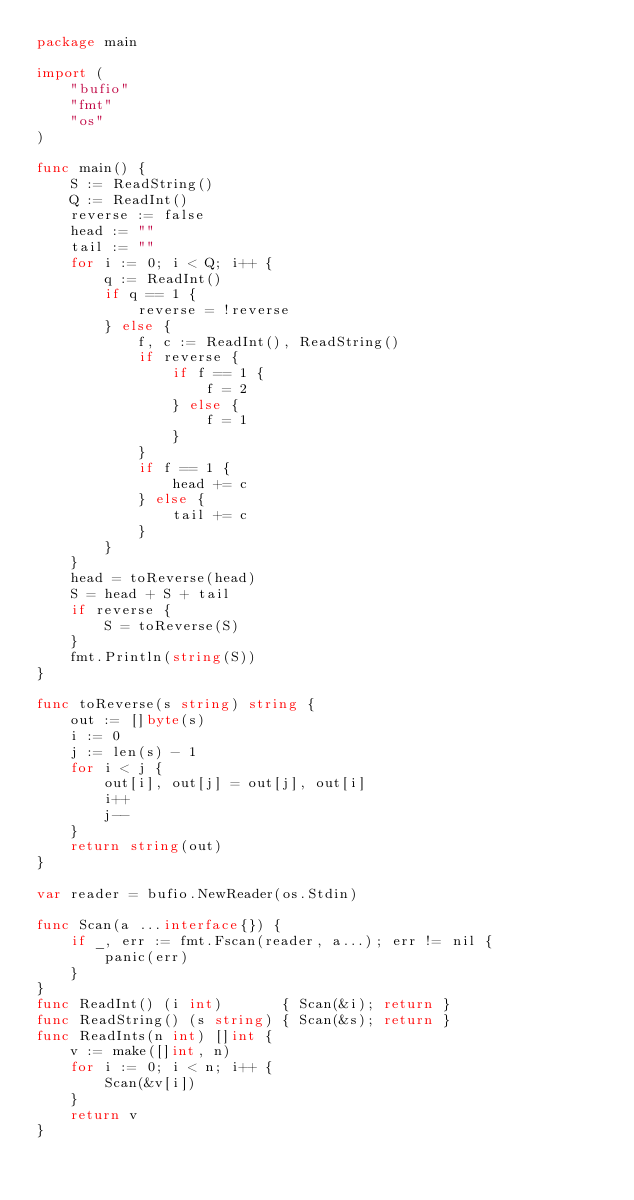<code> <loc_0><loc_0><loc_500><loc_500><_Go_>package main

import (
	"bufio"
	"fmt"
	"os"
)

func main() {
	S := ReadString()
	Q := ReadInt()
	reverse := false
	head := ""
	tail := ""
	for i := 0; i < Q; i++ {
		q := ReadInt()
		if q == 1 {
			reverse = !reverse
		} else {
			f, c := ReadInt(), ReadString()
			if reverse {
				if f == 1 {
					f = 2
				} else {
					f = 1
				}
			}
			if f == 1 {
				head += c
			} else {
				tail += c
			}
		}
	}
	head = toReverse(head)
	S = head + S + tail
	if reverse {
		S = toReverse(S)
	}
	fmt.Println(string(S))
}

func toReverse(s string) string {
	out := []byte(s)
	i := 0
	j := len(s) - 1
	for i < j {
		out[i], out[j] = out[j], out[i]
		i++
		j--
	}
	return string(out)
}

var reader = bufio.NewReader(os.Stdin)

func Scan(a ...interface{}) {
	if _, err := fmt.Fscan(reader, a...); err != nil {
		panic(err)
	}
}
func ReadInt() (i int)       { Scan(&i); return }
func ReadString() (s string) { Scan(&s); return }
func ReadInts(n int) []int {
	v := make([]int, n)
	for i := 0; i < n; i++ {
		Scan(&v[i])
	}
	return v
}
</code> 